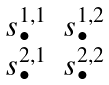Convert formula to latex. <formula><loc_0><loc_0><loc_500><loc_500>\begin{matrix} s ^ { 1 , 1 } _ { \bullet } & s ^ { 1 , 2 } _ { \bullet } \\ s ^ { 2 , 1 } _ { \bullet } & s ^ { 2 , 2 } _ { \bullet } \end{matrix}</formula> 